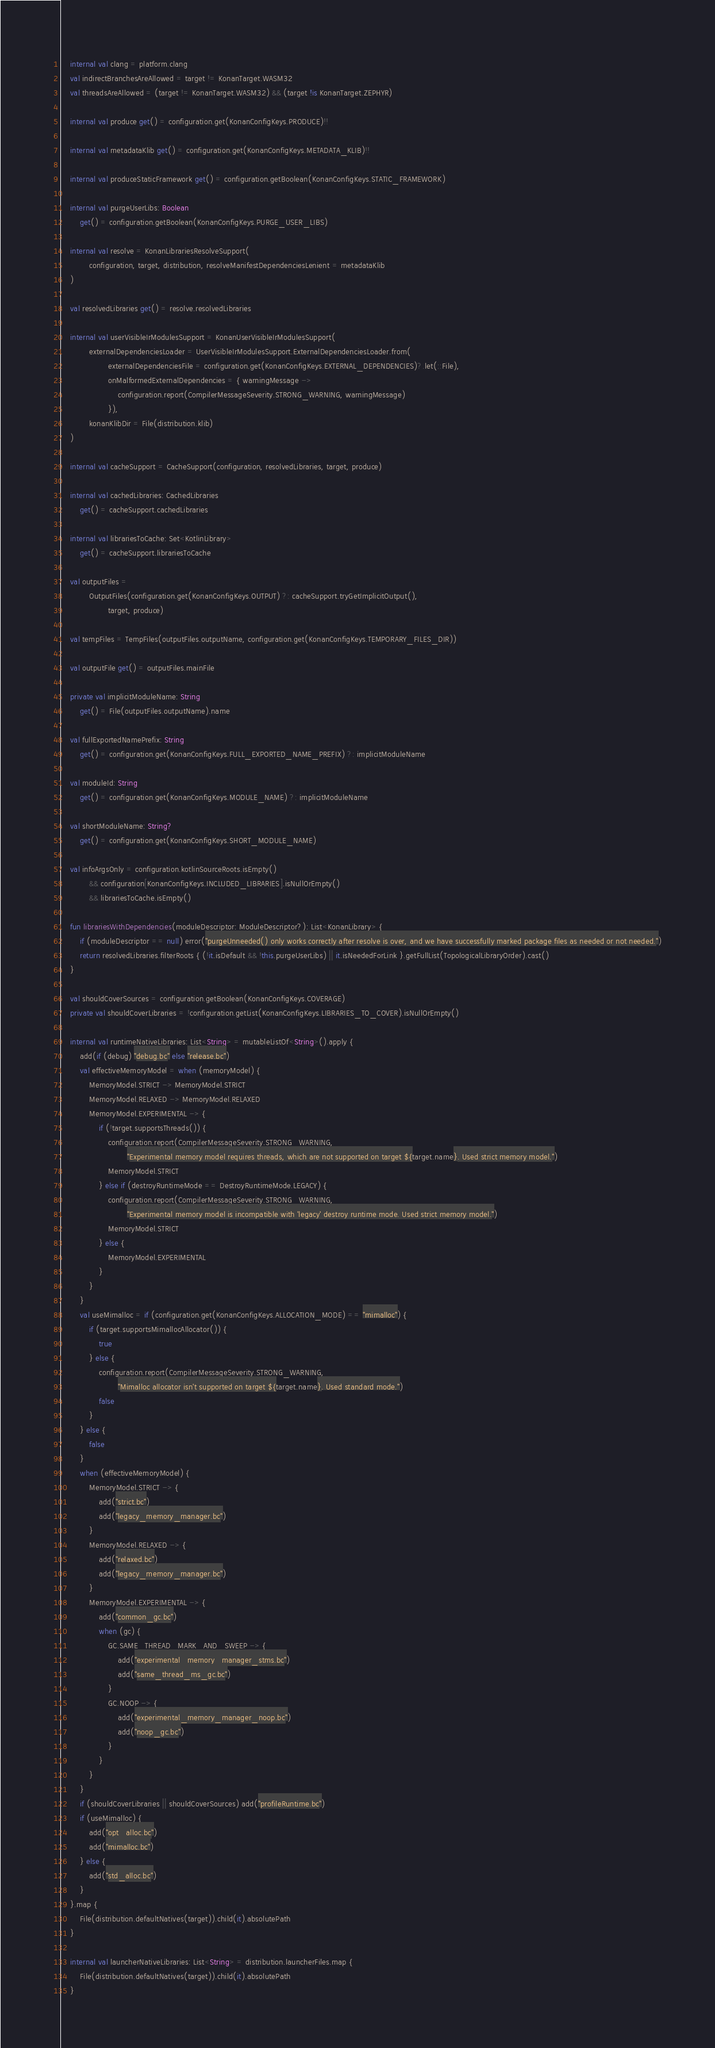<code> <loc_0><loc_0><loc_500><loc_500><_Kotlin_>    internal val clang = platform.clang
    val indirectBranchesAreAllowed = target != KonanTarget.WASM32
    val threadsAreAllowed = (target != KonanTarget.WASM32) && (target !is KonanTarget.ZEPHYR)

    internal val produce get() = configuration.get(KonanConfigKeys.PRODUCE)!!

    internal val metadataKlib get() = configuration.get(KonanConfigKeys.METADATA_KLIB)!!

    internal val produceStaticFramework get() = configuration.getBoolean(KonanConfigKeys.STATIC_FRAMEWORK)

    internal val purgeUserLibs: Boolean
        get() = configuration.getBoolean(KonanConfigKeys.PURGE_USER_LIBS)

    internal val resolve = KonanLibrariesResolveSupport(
            configuration, target, distribution, resolveManifestDependenciesLenient = metadataKlib
    )

    val resolvedLibraries get() = resolve.resolvedLibraries

    internal val userVisibleIrModulesSupport = KonanUserVisibleIrModulesSupport(
            externalDependenciesLoader = UserVisibleIrModulesSupport.ExternalDependenciesLoader.from(
                    externalDependenciesFile = configuration.get(KonanConfigKeys.EXTERNAL_DEPENDENCIES)?.let(::File),
                    onMalformedExternalDependencies = { warningMessage ->
                        configuration.report(CompilerMessageSeverity.STRONG_WARNING, warningMessage)
                    }),
            konanKlibDir = File(distribution.klib)
    )

    internal val cacheSupport = CacheSupport(configuration, resolvedLibraries, target, produce)

    internal val cachedLibraries: CachedLibraries
        get() = cacheSupport.cachedLibraries

    internal val librariesToCache: Set<KotlinLibrary>
        get() = cacheSupport.librariesToCache

    val outputFiles =
            OutputFiles(configuration.get(KonanConfigKeys.OUTPUT) ?: cacheSupport.tryGetImplicitOutput(),
                    target, produce)

    val tempFiles = TempFiles(outputFiles.outputName, configuration.get(KonanConfigKeys.TEMPORARY_FILES_DIR))

    val outputFile get() = outputFiles.mainFile

    private val implicitModuleName: String
        get() = File(outputFiles.outputName).name

    val fullExportedNamePrefix: String
        get() = configuration.get(KonanConfigKeys.FULL_EXPORTED_NAME_PREFIX) ?: implicitModuleName

    val moduleId: String
        get() = configuration.get(KonanConfigKeys.MODULE_NAME) ?: implicitModuleName

    val shortModuleName: String?
        get() = configuration.get(KonanConfigKeys.SHORT_MODULE_NAME)

    val infoArgsOnly = configuration.kotlinSourceRoots.isEmpty()
            && configuration[KonanConfigKeys.INCLUDED_LIBRARIES].isNullOrEmpty()
            && librariesToCache.isEmpty()

    fun librariesWithDependencies(moduleDescriptor: ModuleDescriptor?): List<KonanLibrary> {
        if (moduleDescriptor == null) error("purgeUnneeded() only works correctly after resolve is over, and we have successfully marked package files as needed or not needed.")
        return resolvedLibraries.filterRoots { (!it.isDefault && !this.purgeUserLibs) || it.isNeededForLink }.getFullList(TopologicalLibraryOrder).cast()
    }

    val shouldCoverSources = configuration.getBoolean(KonanConfigKeys.COVERAGE)
    private val shouldCoverLibraries = !configuration.getList(KonanConfigKeys.LIBRARIES_TO_COVER).isNullOrEmpty()

    internal val runtimeNativeLibraries: List<String> = mutableListOf<String>().apply {
        add(if (debug) "debug.bc" else "release.bc")
        val effectiveMemoryModel = when (memoryModel) {
            MemoryModel.STRICT -> MemoryModel.STRICT
            MemoryModel.RELAXED -> MemoryModel.RELAXED
            MemoryModel.EXPERIMENTAL -> {
                if (!target.supportsThreads()) {
                    configuration.report(CompilerMessageSeverity.STRONG_WARNING,
                            "Experimental memory model requires threads, which are not supported on target ${target.name}. Used strict memory model.")
                    MemoryModel.STRICT
                } else if (destroyRuntimeMode == DestroyRuntimeMode.LEGACY) {
                    configuration.report(CompilerMessageSeverity.STRONG_WARNING,
                            "Experimental memory model is incompatible with 'legacy' destroy runtime mode. Used strict memory model.")
                    MemoryModel.STRICT
                } else {
                    MemoryModel.EXPERIMENTAL
                }
            }
        }
        val useMimalloc = if (configuration.get(KonanConfigKeys.ALLOCATION_MODE) == "mimalloc") {
            if (target.supportsMimallocAllocator()) {
                true
            } else {
                configuration.report(CompilerMessageSeverity.STRONG_WARNING,
                        "Mimalloc allocator isn't supported on target ${target.name}. Used standard mode.")
                false
            }
        } else {
            false
        }
        when (effectiveMemoryModel) {
            MemoryModel.STRICT -> {
                add("strict.bc")
                add("legacy_memory_manager.bc")
            }
            MemoryModel.RELAXED -> {
                add("relaxed.bc")
                add("legacy_memory_manager.bc")
            }
            MemoryModel.EXPERIMENTAL -> {
                add("common_gc.bc")
                when (gc) {
                    GC.SAME_THREAD_MARK_AND_SWEEP -> {
                        add("experimental_memory_manager_stms.bc")
                        add("same_thread_ms_gc.bc")
                    }
                    GC.NOOP -> {
                        add("experimental_memory_manager_noop.bc")
                        add("noop_gc.bc")
                    }
                }
            }
        }
        if (shouldCoverLibraries || shouldCoverSources) add("profileRuntime.bc")
        if (useMimalloc) {
            add("opt_alloc.bc")
            add("mimalloc.bc")
        } else {
            add("std_alloc.bc")
        }
    }.map {
        File(distribution.defaultNatives(target)).child(it).absolutePath
    }

    internal val launcherNativeLibraries: List<String> = distribution.launcherFiles.map {
        File(distribution.defaultNatives(target)).child(it).absolutePath
    }
</code> 